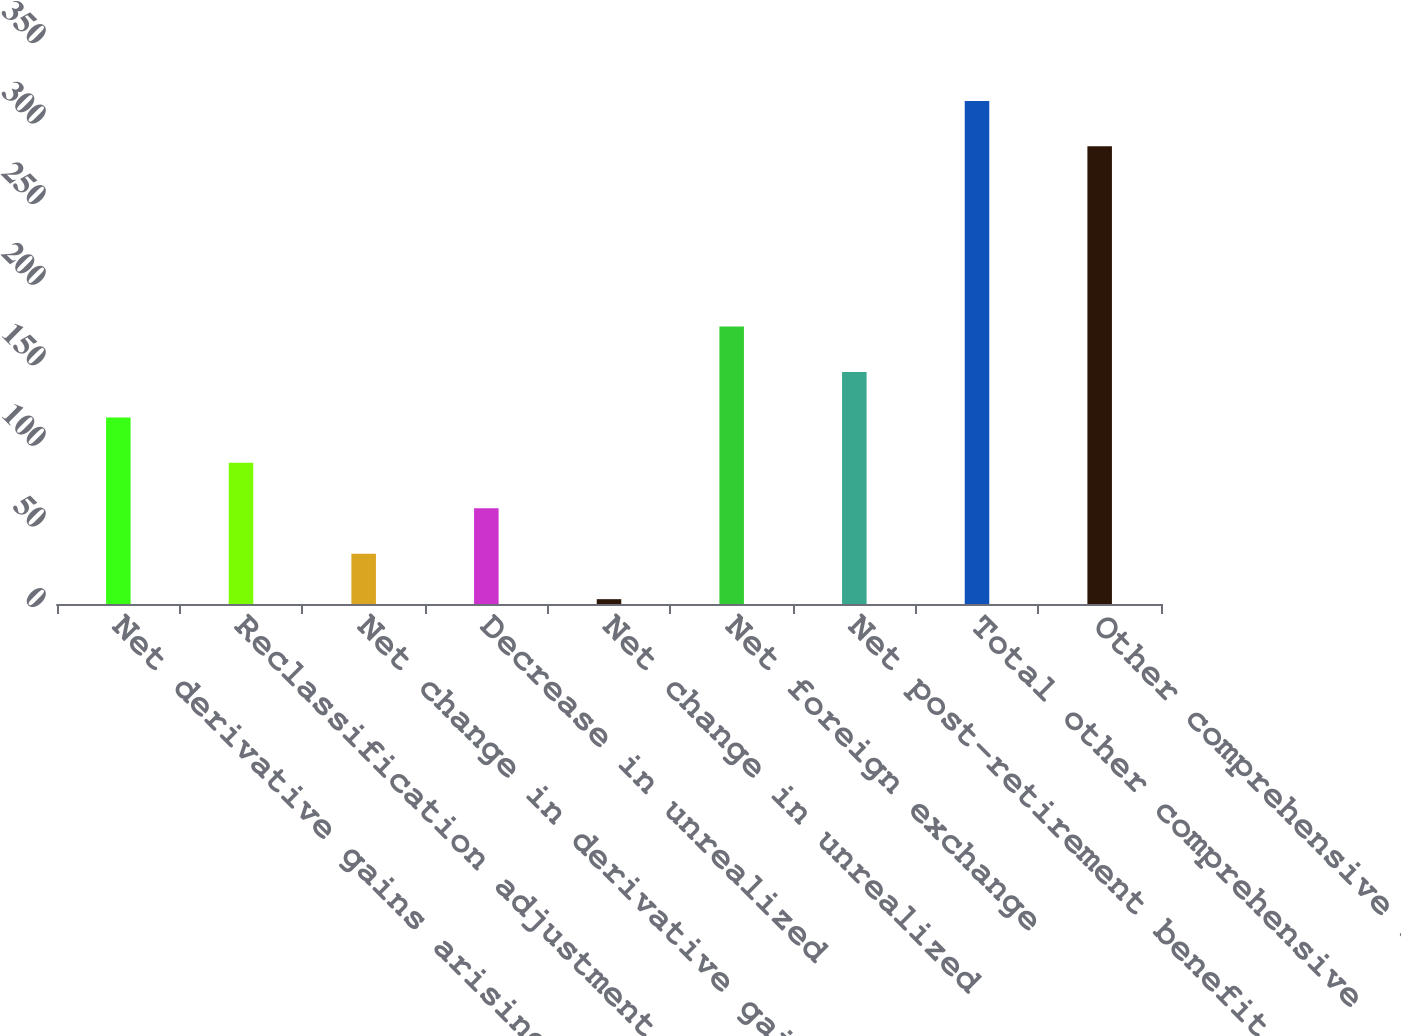<chart> <loc_0><loc_0><loc_500><loc_500><bar_chart><fcel>Net derivative gains arising<fcel>Reclassification adjustment<fcel>Net change in derivative gains<fcel>Decrease in unrealized<fcel>Net change in unrealized<fcel>Net foreign exchange<fcel>Net post-retirement benefit<fcel>Total other comprehensive<fcel>Other comprehensive income<nl><fcel>115.8<fcel>87.6<fcel>31.2<fcel>59.4<fcel>3<fcel>172.2<fcel>144<fcel>312.2<fcel>284<nl></chart> 